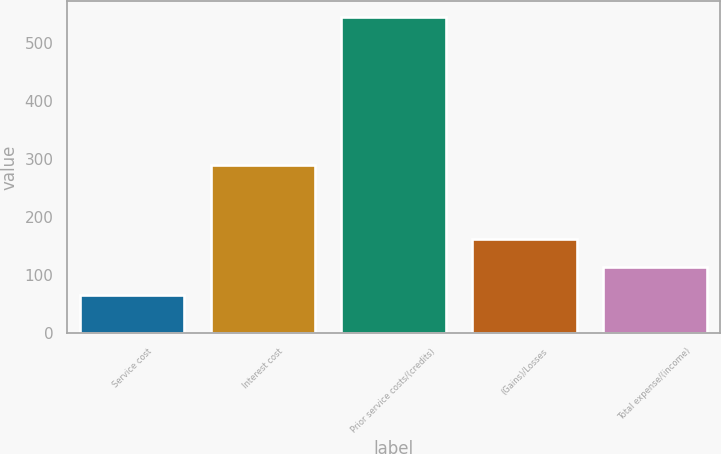Convert chart. <chart><loc_0><loc_0><loc_500><loc_500><bar_chart><fcel>Service cost<fcel>Interest cost<fcel>Prior service costs/(credits)<fcel>(Gains)/Losses<fcel>Total expense/(income)<nl><fcel>67<fcel>290<fcel>545<fcel>162.6<fcel>114.8<nl></chart> 